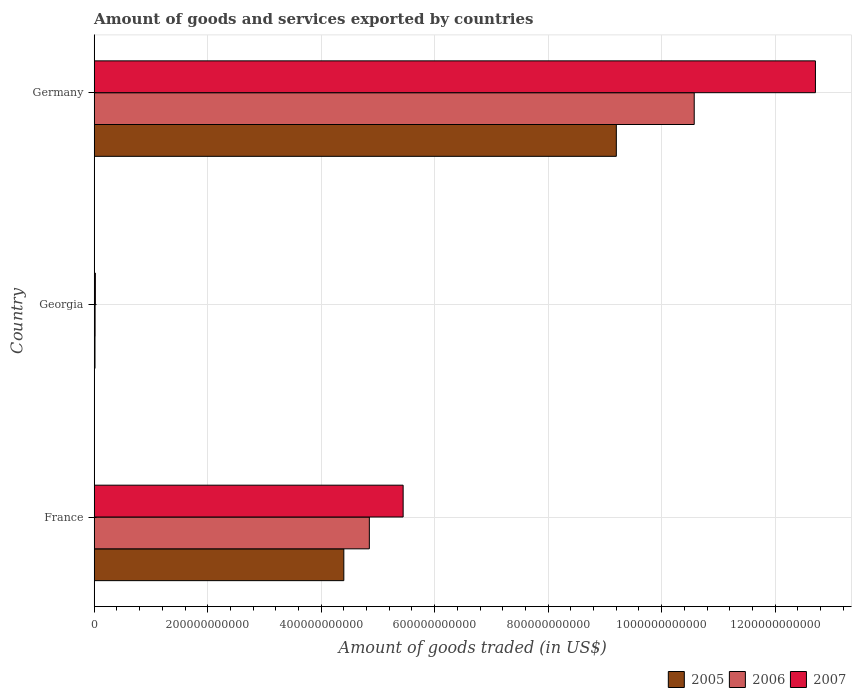Are the number of bars on each tick of the Y-axis equal?
Offer a terse response. Yes. How many bars are there on the 3rd tick from the top?
Provide a succinct answer. 3. What is the label of the 1st group of bars from the top?
Give a very brief answer. Germany. What is the total amount of goods and services exported in 2006 in Georgia?
Keep it short and to the point. 1.59e+09. Across all countries, what is the maximum total amount of goods and services exported in 2007?
Your response must be concise. 1.27e+12. Across all countries, what is the minimum total amount of goods and services exported in 2006?
Offer a very short reply. 1.59e+09. In which country was the total amount of goods and services exported in 2005 minimum?
Your response must be concise. Georgia. What is the total total amount of goods and services exported in 2006 in the graph?
Ensure brevity in your answer.  1.54e+12. What is the difference between the total amount of goods and services exported in 2005 in France and that in Georgia?
Your response must be concise. 4.38e+11. What is the difference between the total amount of goods and services exported in 2007 in Germany and the total amount of goods and services exported in 2005 in France?
Your answer should be very brief. 8.31e+11. What is the average total amount of goods and services exported in 2006 per country?
Offer a terse response. 5.15e+11. What is the difference between the total amount of goods and services exported in 2005 and total amount of goods and services exported in 2007 in France?
Give a very brief answer. -1.05e+11. What is the ratio of the total amount of goods and services exported in 2006 in Georgia to that in Germany?
Keep it short and to the point. 0. Is the difference between the total amount of goods and services exported in 2005 in France and Germany greater than the difference between the total amount of goods and services exported in 2007 in France and Germany?
Ensure brevity in your answer.  Yes. What is the difference between the highest and the second highest total amount of goods and services exported in 2006?
Give a very brief answer. 5.72e+11. What is the difference between the highest and the lowest total amount of goods and services exported in 2007?
Your answer should be very brief. 1.27e+12. What does the 2nd bar from the top in France represents?
Provide a succinct answer. 2006. What does the 3rd bar from the bottom in France represents?
Offer a very short reply. 2007. Are all the bars in the graph horizontal?
Provide a short and direct response. Yes. What is the difference between two consecutive major ticks on the X-axis?
Provide a short and direct response. 2.00e+11. Where does the legend appear in the graph?
Ensure brevity in your answer.  Bottom right. How are the legend labels stacked?
Provide a short and direct response. Horizontal. What is the title of the graph?
Provide a succinct answer. Amount of goods and services exported by countries. Does "1960" appear as one of the legend labels in the graph?
Your answer should be compact. No. What is the label or title of the X-axis?
Offer a terse response. Amount of goods traded (in US$). What is the label or title of the Y-axis?
Offer a terse response. Country. What is the Amount of goods traded (in US$) in 2005 in France?
Your response must be concise. 4.40e+11. What is the Amount of goods traded (in US$) of 2006 in France?
Offer a very short reply. 4.85e+11. What is the Amount of goods traded (in US$) of 2007 in France?
Your answer should be very brief. 5.44e+11. What is the Amount of goods traded (in US$) of 2005 in Georgia?
Keep it short and to the point. 1.41e+09. What is the Amount of goods traded (in US$) in 2006 in Georgia?
Ensure brevity in your answer.  1.59e+09. What is the Amount of goods traded (in US$) in 2007 in Georgia?
Provide a succinct answer. 2.06e+09. What is the Amount of goods traded (in US$) in 2005 in Germany?
Your response must be concise. 9.20e+11. What is the Amount of goods traded (in US$) in 2006 in Germany?
Provide a succinct answer. 1.06e+12. What is the Amount of goods traded (in US$) of 2007 in Germany?
Provide a succinct answer. 1.27e+12. Across all countries, what is the maximum Amount of goods traded (in US$) in 2005?
Offer a terse response. 9.20e+11. Across all countries, what is the maximum Amount of goods traded (in US$) in 2006?
Make the answer very short. 1.06e+12. Across all countries, what is the maximum Amount of goods traded (in US$) of 2007?
Ensure brevity in your answer.  1.27e+12. Across all countries, what is the minimum Amount of goods traded (in US$) in 2005?
Offer a very short reply. 1.41e+09. Across all countries, what is the minimum Amount of goods traded (in US$) of 2006?
Provide a succinct answer. 1.59e+09. Across all countries, what is the minimum Amount of goods traded (in US$) in 2007?
Ensure brevity in your answer.  2.06e+09. What is the total Amount of goods traded (in US$) of 2005 in the graph?
Ensure brevity in your answer.  1.36e+12. What is the total Amount of goods traded (in US$) in 2006 in the graph?
Offer a terse response. 1.54e+12. What is the total Amount of goods traded (in US$) of 2007 in the graph?
Provide a short and direct response. 1.82e+12. What is the difference between the Amount of goods traded (in US$) of 2005 in France and that in Georgia?
Make the answer very short. 4.38e+11. What is the difference between the Amount of goods traded (in US$) of 2006 in France and that in Georgia?
Your answer should be very brief. 4.83e+11. What is the difference between the Amount of goods traded (in US$) of 2007 in France and that in Georgia?
Your response must be concise. 5.42e+11. What is the difference between the Amount of goods traded (in US$) of 2005 in France and that in Germany?
Provide a succinct answer. -4.80e+11. What is the difference between the Amount of goods traded (in US$) in 2006 in France and that in Germany?
Provide a short and direct response. -5.72e+11. What is the difference between the Amount of goods traded (in US$) of 2007 in France and that in Germany?
Provide a short and direct response. -7.27e+11. What is the difference between the Amount of goods traded (in US$) in 2005 in Georgia and that in Germany?
Provide a succinct answer. -9.19e+11. What is the difference between the Amount of goods traded (in US$) of 2006 in Georgia and that in Germany?
Provide a short and direct response. -1.06e+12. What is the difference between the Amount of goods traded (in US$) of 2007 in Georgia and that in Germany?
Provide a short and direct response. -1.27e+12. What is the difference between the Amount of goods traded (in US$) of 2005 in France and the Amount of goods traded (in US$) of 2006 in Georgia?
Give a very brief answer. 4.38e+11. What is the difference between the Amount of goods traded (in US$) in 2005 in France and the Amount of goods traded (in US$) in 2007 in Georgia?
Provide a succinct answer. 4.38e+11. What is the difference between the Amount of goods traded (in US$) of 2006 in France and the Amount of goods traded (in US$) of 2007 in Georgia?
Offer a very short reply. 4.83e+11. What is the difference between the Amount of goods traded (in US$) of 2005 in France and the Amount of goods traded (in US$) of 2006 in Germany?
Your answer should be compact. -6.17e+11. What is the difference between the Amount of goods traded (in US$) in 2005 in France and the Amount of goods traded (in US$) in 2007 in Germany?
Ensure brevity in your answer.  -8.31e+11. What is the difference between the Amount of goods traded (in US$) of 2006 in France and the Amount of goods traded (in US$) of 2007 in Germany?
Offer a very short reply. -7.86e+11. What is the difference between the Amount of goods traded (in US$) in 2005 in Georgia and the Amount of goods traded (in US$) in 2006 in Germany?
Offer a very short reply. -1.06e+12. What is the difference between the Amount of goods traded (in US$) in 2005 in Georgia and the Amount of goods traded (in US$) in 2007 in Germany?
Make the answer very short. -1.27e+12. What is the difference between the Amount of goods traded (in US$) in 2006 in Georgia and the Amount of goods traded (in US$) in 2007 in Germany?
Ensure brevity in your answer.  -1.27e+12. What is the average Amount of goods traded (in US$) in 2005 per country?
Provide a short and direct response. 4.54e+11. What is the average Amount of goods traded (in US$) of 2006 per country?
Keep it short and to the point. 5.15e+11. What is the average Amount of goods traded (in US$) in 2007 per country?
Your answer should be compact. 6.06e+11. What is the difference between the Amount of goods traded (in US$) of 2005 and Amount of goods traded (in US$) of 2006 in France?
Offer a terse response. -4.50e+1. What is the difference between the Amount of goods traded (in US$) of 2005 and Amount of goods traded (in US$) of 2007 in France?
Ensure brevity in your answer.  -1.05e+11. What is the difference between the Amount of goods traded (in US$) of 2006 and Amount of goods traded (in US$) of 2007 in France?
Provide a succinct answer. -5.96e+1. What is the difference between the Amount of goods traded (in US$) of 2005 and Amount of goods traded (in US$) of 2006 in Georgia?
Provide a short and direct response. -1.73e+08. What is the difference between the Amount of goods traded (in US$) in 2005 and Amount of goods traded (in US$) in 2007 in Georgia?
Provide a short and direct response. -6.42e+08. What is the difference between the Amount of goods traded (in US$) in 2006 and Amount of goods traded (in US$) in 2007 in Georgia?
Offer a terse response. -4.69e+08. What is the difference between the Amount of goods traded (in US$) of 2005 and Amount of goods traded (in US$) of 2006 in Germany?
Offer a terse response. -1.37e+11. What is the difference between the Amount of goods traded (in US$) of 2005 and Amount of goods traded (in US$) of 2007 in Germany?
Your answer should be very brief. -3.51e+11. What is the difference between the Amount of goods traded (in US$) of 2006 and Amount of goods traded (in US$) of 2007 in Germany?
Keep it short and to the point. -2.14e+11. What is the ratio of the Amount of goods traded (in US$) in 2005 in France to that in Georgia?
Make the answer very short. 311.12. What is the ratio of the Amount of goods traded (in US$) of 2006 in France to that in Georgia?
Your answer should be very brief. 305.63. What is the ratio of the Amount of goods traded (in US$) of 2007 in France to that in Georgia?
Provide a short and direct response. 264.84. What is the ratio of the Amount of goods traded (in US$) in 2005 in France to that in Germany?
Give a very brief answer. 0.48. What is the ratio of the Amount of goods traded (in US$) in 2006 in France to that in Germany?
Ensure brevity in your answer.  0.46. What is the ratio of the Amount of goods traded (in US$) in 2007 in France to that in Germany?
Provide a short and direct response. 0.43. What is the ratio of the Amount of goods traded (in US$) of 2005 in Georgia to that in Germany?
Make the answer very short. 0. What is the ratio of the Amount of goods traded (in US$) in 2006 in Georgia to that in Germany?
Your answer should be compact. 0. What is the ratio of the Amount of goods traded (in US$) in 2007 in Georgia to that in Germany?
Offer a terse response. 0. What is the difference between the highest and the second highest Amount of goods traded (in US$) in 2005?
Ensure brevity in your answer.  4.80e+11. What is the difference between the highest and the second highest Amount of goods traded (in US$) in 2006?
Ensure brevity in your answer.  5.72e+11. What is the difference between the highest and the second highest Amount of goods traded (in US$) in 2007?
Provide a succinct answer. 7.27e+11. What is the difference between the highest and the lowest Amount of goods traded (in US$) in 2005?
Offer a very short reply. 9.19e+11. What is the difference between the highest and the lowest Amount of goods traded (in US$) of 2006?
Make the answer very short. 1.06e+12. What is the difference between the highest and the lowest Amount of goods traded (in US$) in 2007?
Offer a very short reply. 1.27e+12. 